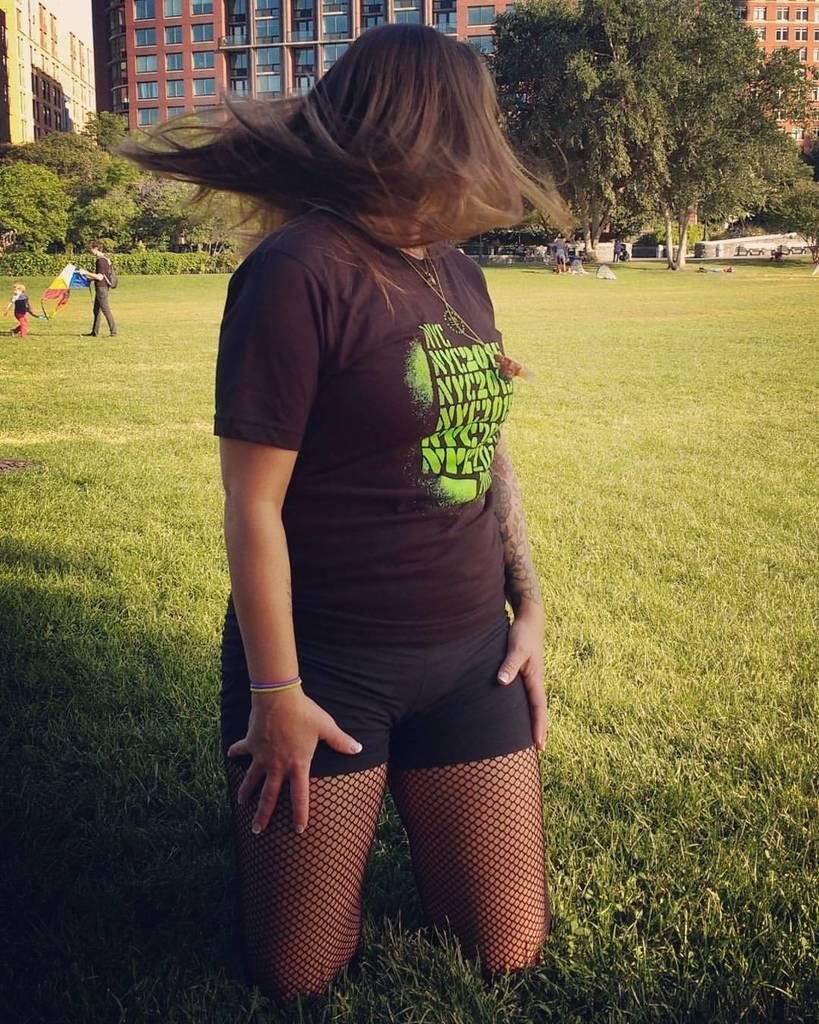Who is the main subject in the image? There is a woman in the image. Where is the woman located? The woman is on the grass. What can be seen in the background of the image? There is a man holding a kite, a child, buildings with windows, and trees in the background of the image. What type of vase is placed on the seat in the image? There is no vase or seat present in the image. What message of peace can be seen in the image? There is no message of peace depicted in the image. 